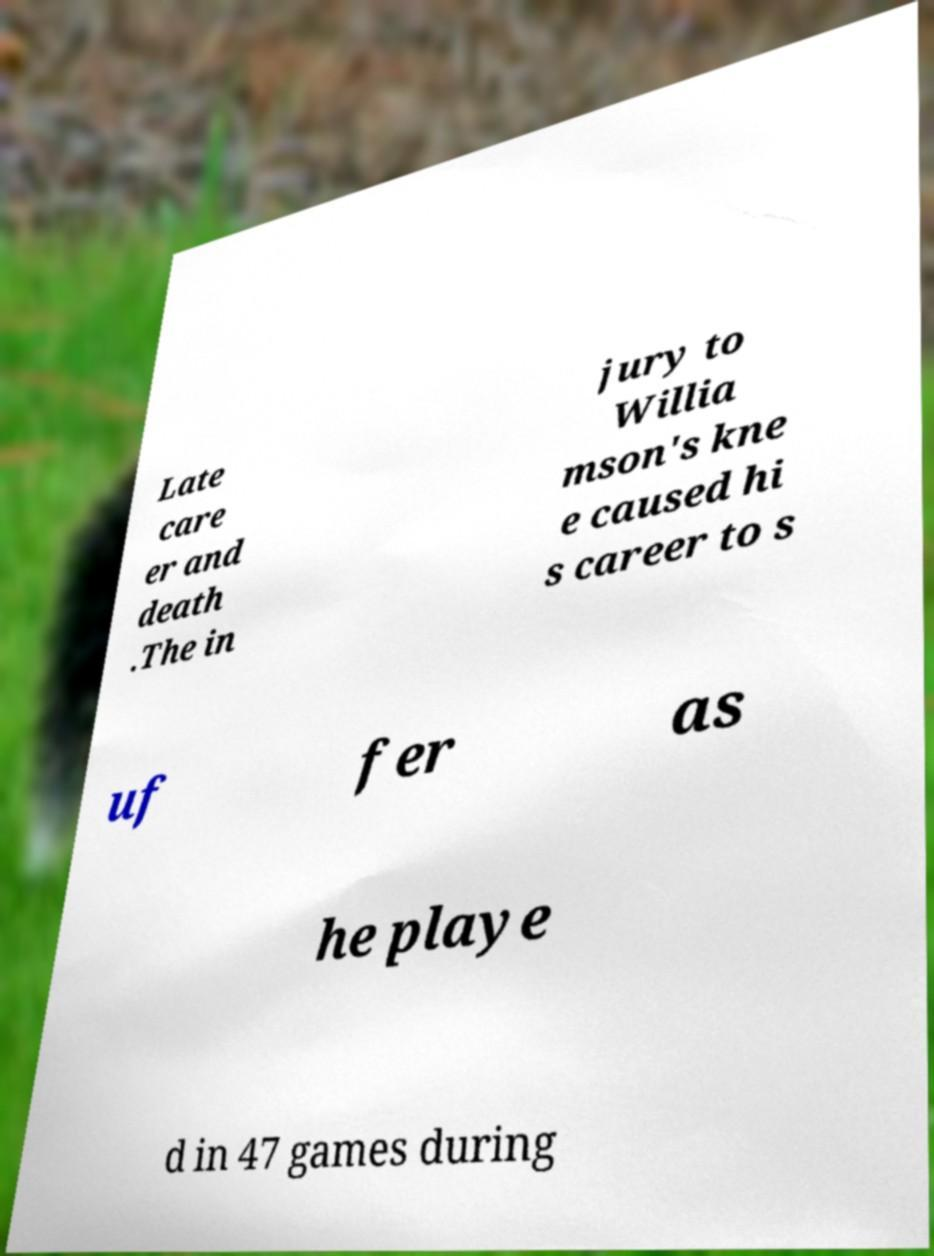Could you extract and type out the text from this image? Late care er and death .The in jury to Willia mson's kne e caused hi s career to s uf fer as he playe d in 47 games during 